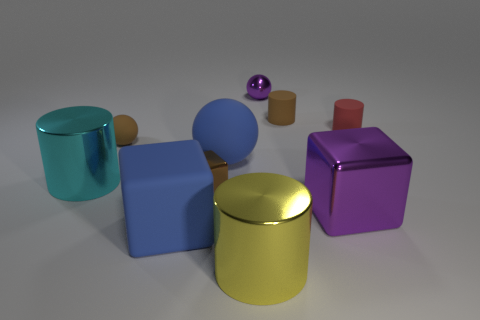Subtract all metallic spheres. How many spheres are left? 2 Subtract all cyan cylinders. How many cylinders are left? 3 Subtract all cylinders. How many objects are left? 6 Subtract 2 cubes. How many cubes are left? 1 Subtract all small purple shiny objects. Subtract all purple cubes. How many objects are left? 8 Add 3 big yellow cylinders. How many big yellow cylinders are left? 4 Add 5 brown rubber spheres. How many brown rubber spheres exist? 6 Subtract 1 brown blocks. How many objects are left? 9 Subtract all yellow cylinders. Subtract all blue balls. How many cylinders are left? 3 